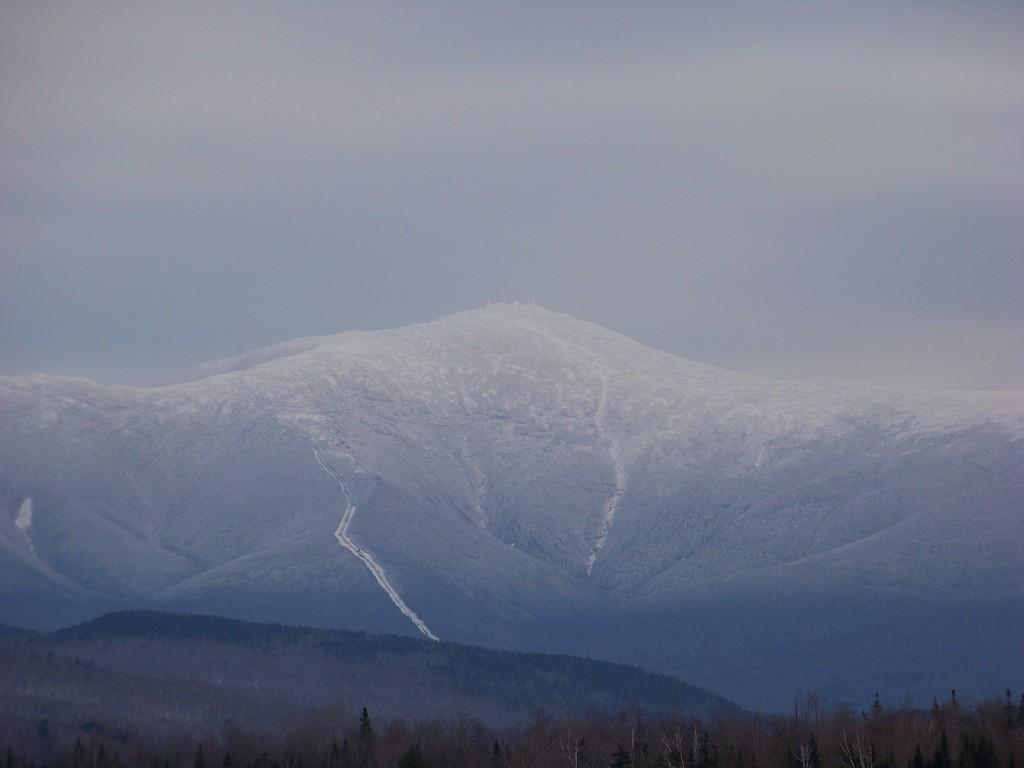What type of vegetation is in the foreground of the image? There is a group of trees in the foreground of the image. What natural features can be seen in the background of the image? Mountains and the sky are visible in the background of the image. How many clovers can be seen growing among the trees in the image? There is no mention of clovers in the image, so it is not possible to determine their presence or quantity. 